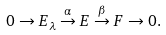Convert formula to latex. <formula><loc_0><loc_0><loc_500><loc_500>0 \to E _ { \lambda } \overset { \alpha } { \to } E \overset { \beta } { \to } F \to 0 .</formula> 